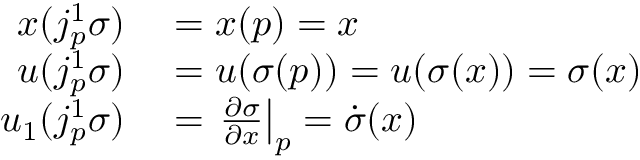Convert formula to latex. <formula><loc_0><loc_0><loc_500><loc_500>\begin{array} { r l } { x ( j _ { p } ^ { 1 } \sigma ) } & = x ( p ) = x } \\ { u ( j _ { p } ^ { 1 } \sigma ) } & = u ( \sigma ( p ) ) = u ( \sigma ( x ) ) = \sigma ( x ) } \\ { u _ { 1 } ( j _ { p } ^ { 1 } \sigma ) } & = { \frac { \partial \sigma } { \partial x } } \right | _ { p } = { \dot { \sigma } } ( x ) } \end{array}</formula> 